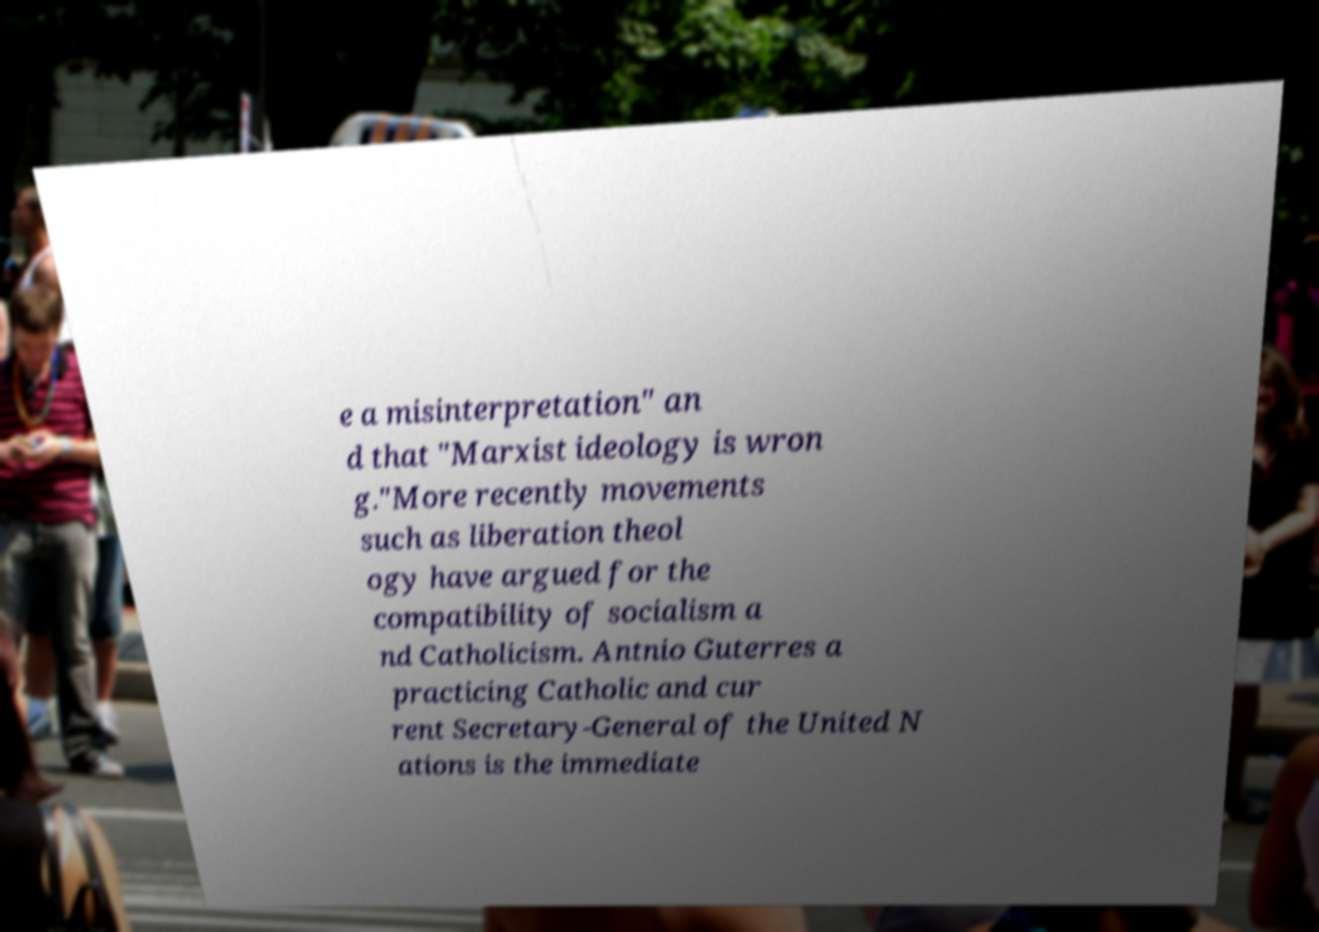Please identify and transcribe the text found in this image. e a misinterpretation" an d that "Marxist ideology is wron g."More recently movements such as liberation theol ogy have argued for the compatibility of socialism a nd Catholicism. Antnio Guterres a practicing Catholic and cur rent Secretary-General of the United N ations is the immediate 